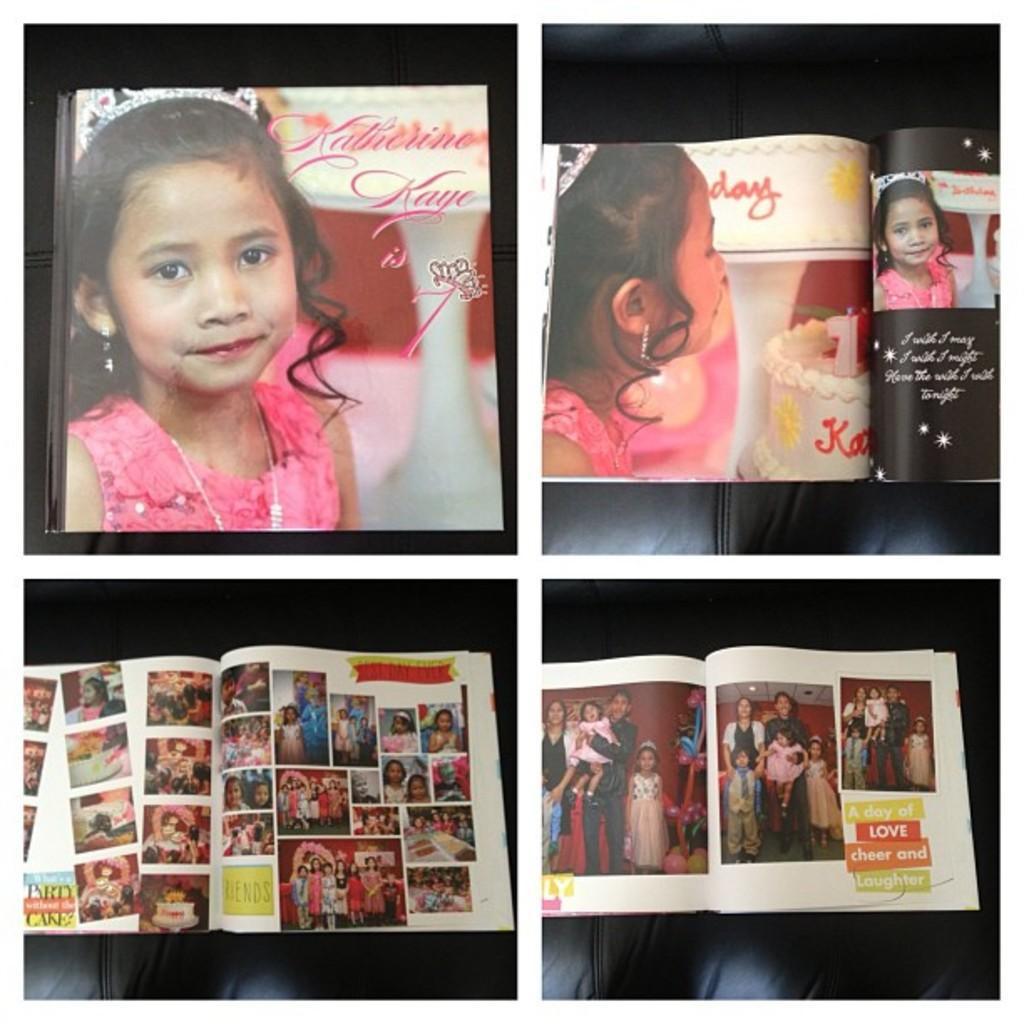Could you give a brief overview of what you see in this image? This is a collage image of different photographs of the girl. 